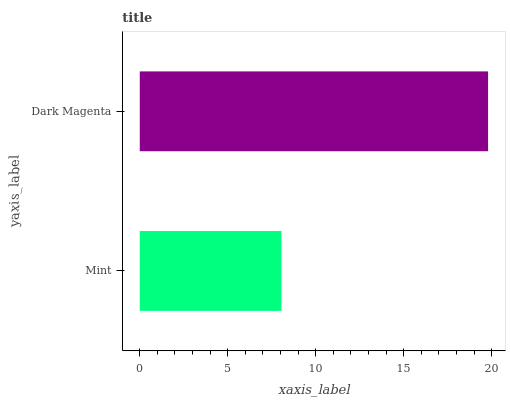Is Mint the minimum?
Answer yes or no. Yes. Is Dark Magenta the maximum?
Answer yes or no. Yes. Is Dark Magenta the minimum?
Answer yes or no. No. Is Dark Magenta greater than Mint?
Answer yes or no. Yes. Is Mint less than Dark Magenta?
Answer yes or no. Yes. Is Mint greater than Dark Magenta?
Answer yes or no. No. Is Dark Magenta less than Mint?
Answer yes or no. No. Is Dark Magenta the high median?
Answer yes or no. Yes. Is Mint the low median?
Answer yes or no. Yes. Is Mint the high median?
Answer yes or no. No. Is Dark Magenta the low median?
Answer yes or no. No. 